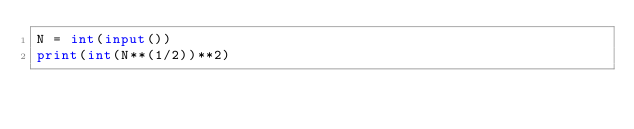Convert code to text. <code><loc_0><loc_0><loc_500><loc_500><_Python_>N = int(input())
print(int(N**(1/2))**2)</code> 